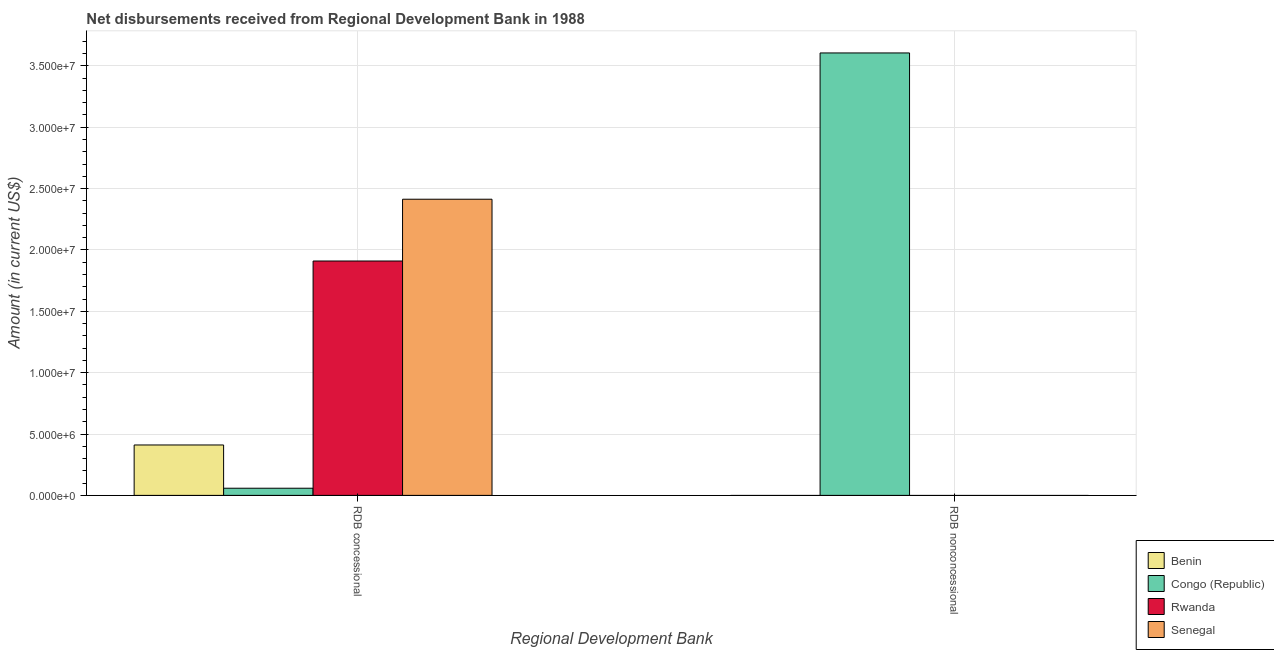How many different coloured bars are there?
Make the answer very short. 4. Are the number of bars per tick equal to the number of legend labels?
Provide a succinct answer. No. How many bars are there on the 2nd tick from the left?
Offer a very short reply. 1. What is the label of the 1st group of bars from the left?
Make the answer very short. RDB concessional. What is the net concessional disbursements from rdb in Senegal?
Make the answer very short. 2.41e+07. Across all countries, what is the maximum net non concessional disbursements from rdb?
Make the answer very short. 3.60e+07. Across all countries, what is the minimum net concessional disbursements from rdb?
Make the answer very short. 5.84e+05. In which country was the net non concessional disbursements from rdb maximum?
Offer a terse response. Congo (Republic). What is the total net non concessional disbursements from rdb in the graph?
Your answer should be compact. 3.60e+07. What is the difference between the net concessional disbursements from rdb in Senegal and that in Benin?
Your answer should be very brief. 2.00e+07. What is the difference between the net concessional disbursements from rdb in Rwanda and the net non concessional disbursements from rdb in Benin?
Your response must be concise. 1.91e+07. What is the average net concessional disbursements from rdb per country?
Make the answer very short. 1.20e+07. What is the difference between the net non concessional disbursements from rdb and net concessional disbursements from rdb in Congo (Republic)?
Offer a very short reply. 3.55e+07. What is the ratio of the net concessional disbursements from rdb in Benin to that in Rwanda?
Your answer should be compact. 0.22. Is the net concessional disbursements from rdb in Rwanda less than that in Senegal?
Offer a terse response. Yes. In how many countries, is the net concessional disbursements from rdb greater than the average net concessional disbursements from rdb taken over all countries?
Your answer should be compact. 2. How many countries are there in the graph?
Offer a very short reply. 4. What is the difference between two consecutive major ticks on the Y-axis?
Provide a succinct answer. 5.00e+06. Does the graph contain any zero values?
Keep it short and to the point. Yes. Where does the legend appear in the graph?
Provide a succinct answer. Bottom right. How are the legend labels stacked?
Your answer should be very brief. Vertical. What is the title of the graph?
Provide a short and direct response. Net disbursements received from Regional Development Bank in 1988. Does "Least developed countries" appear as one of the legend labels in the graph?
Offer a terse response. No. What is the label or title of the X-axis?
Give a very brief answer. Regional Development Bank. What is the Amount (in current US$) of Benin in RDB concessional?
Your answer should be very brief. 4.11e+06. What is the Amount (in current US$) in Congo (Republic) in RDB concessional?
Provide a succinct answer. 5.84e+05. What is the Amount (in current US$) of Rwanda in RDB concessional?
Give a very brief answer. 1.91e+07. What is the Amount (in current US$) in Senegal in RDB concessional?
Your answer should be very brief. 2.41e+07. What is the Amount (in current US$) in Congo (Republic) in RDB nonconcessional?
Your response must be concise. 3.60e+07. What is the Amount (in current US$) in Senegal in RDB nonconcessional?
Ensure brevity in your answer.  0. Across all Regional Development Bank, what is the maximum Amount (in current US$) in Benin?
Provide a short and direct response. 4.11e+06. Across all Regional Development Bank, what is the maximum Amount (in current US$) in Congo (Republic)?
Make the answer very short. 3.60e+07. Across all Regional Development Bank, what is the maximum Amount (in current US$) in Rwanda?
Keep it short and to the point. 1.91e+07. Across all Regional Development Bank, what is the maximum Amount (in current US$) of Senegal?
Your answer should be compact. 2.41e+07. Across all Regional Development Bank, what is the minimum Amount (in current US$) of Congo (Republic)?
Ensure brevity in your answer.  5.84e+05. Across all Regional Development Bank, what is the minimum Amount (in current US$) in Senegal?
Your response must be concise. 0. What is the total Amount (in current US$) in Benin in the graph?
Your answer should be compact. 4.11e+06. What is the total Amount (in current US$) in Congo (Republic) in the graph?
Keep it short and to the point. 3.66e+07. What is the total Amount (in current US$) in Rwanda in the graph?
Your answer should be very brief. 1.91e+07. What is the total Amount (in current US$) of Senegal in the graph?
Keep it short and to the point. 2.41e+07. What is the difference between the Amount (in current US$) in Congo (Republic) in RDB concessional and that in RDB nonconcessional?
Ensure brevity in your answer.  -3.55e+07. What is the difference between the Amount (in current US$) of Benin in RDB concessional and the Amount (in current US$) of Congo (Republic) in RDB nonconcessional?
Your answer should be compact. -3.19e+07. What is the average Amount (in current US$) of Benin per Regional Development Bank?
Provide a succinct answer. 2.05e+06. What is the average Amount (in current US$) in Congo (Republic) per Regional Development Bank?
Your answer should be very brief. 1.83e+07. What is the average Amount (in current US$) of Rwanda per Regional Development Bank?
Offer a very short reply. 9.55e+06. What is the average Amount (in current US$) of Senegal per Regional Development Bank?
Keep it short and to the point. 1.21e+07. What is the difference between the Amount (in current US$) of Benin and Amount (in current US$) of Congo (Republic) in RDB concessional?
Provide a succinct answer. 3.52e+06. What is the difference between the Amount (in current US$) of Benin and Amount (in current US$) of Rwanda in RDB concessional?
Give a very brief answer. -1.50e+07. What is the difference between the Amount (in current US$) of Benin and Amount (in current US$) of Senegal in RDB concessional?
Provide a succinct answer. -2.00e+07. What is the difference between the Amount (in current US$) in Congo (Republic) and Amount (in current US$) in Rwanda in RDB concessional?
Give a very brief answer. -1.85e+07. What is the difference between the Amount (in current US$) in Congo (Republic) and Amount (in current US$) in Senegal in RDB concessional?
Provide a succinct answer. -2.35e+07. What is the difference between the Amount (in current US$) in Rwanda and Amount (in current US$) in Senegal in RDB concessional?
Your answer should be very brief. -5.03e+06. What is the ratio of the Amount (in current US$) of Congo (Republic) in RDB concessional to that in RDB nonconcessional?
Keep it short and to the point. 0.02. What is the difference between the highest and the second highest Amount (in current US$) in Congo (Republic)?
Provide a succinct answer. 3.55e+07. What is the difference between the highest and the lowest Amount (in current US$) in Benin?
Keep it short and to the point. 4.11e+06. What is the difference between the highest and the lowest Amount (in current US$) of Congo (Republic)?
Ensure brevity in your answer.  3.55e+07. What is the difference between the highest and the lowest Amount (in current US$) of Rwanda?
Offer a very short reply. 1.91e+07. What is the difference between the highest and the lowest Amount (in current US$) in Senegal?
Ensure brevity in your answer.  2.41e+07. 